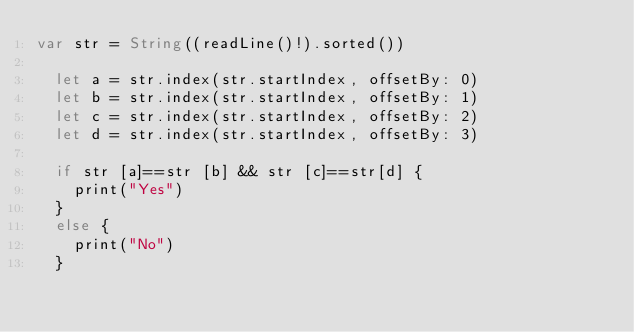<code> <loc_0><loc_0><loc_500><loc_500><_Swift_>var str = String((readLine()!).sorted())

  let a = str.index(str.startIndex, offsetBy: 0)
  let b = str.index(str.startIndex, offsetBy: 1)
  let c = str.index(str.startIndex, offsetBy: 2)
  let d = str.index(str.startIndex, offsetBy: 3)
  
  if str [a]==str [b] && str [c]==str[d] {
    print("Yes")
  }
  else {
    print("No")
  }
</code> 